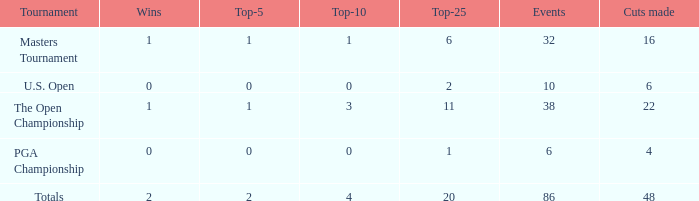Tell me the total number of top 25 for wins less than 1 and cuts made of 22 0.0. 